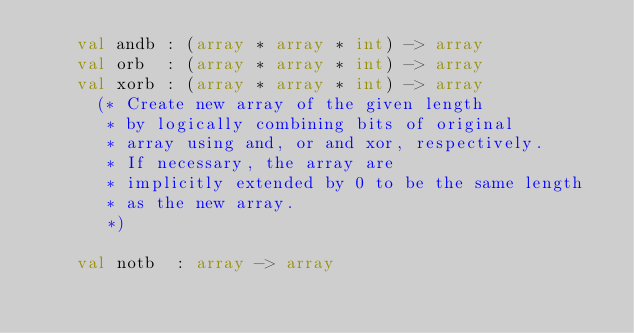<code> <loc_0><loc_0><loc_500><loc_500><_SML_>    val andb : (array * array * int) -> array
    val orb  : (array * array * int) -> array
    val xorb : (array * array * int) -> array
      (* Create new array of the given length
       * by logically combining bits of original
       * array using and, or and xor, respectively.
       * If necessary, the array are
       * implicitly extended by 0 to be the same length
       * as the new array.
       *)

    val notb  : array -> array</code> 